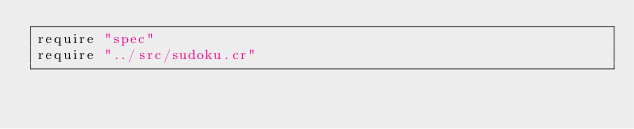<code> <loc_0><loc_0><loc_500><loc_500><_Crystal_>require "spec"
require "../src/sudoku.cr"
</code> 